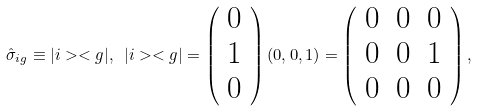<formula> <loc_0><loc_0><loc_500><loc_500>\hat { \sigma } _ { i g } \equiv | i > < g | , \text { } | i > < g | = \left ( \begin{array} { c c c c } 0 \\ 1 \\ 0 \end{array} \right ) ( 0 , 0 , 1 ) = \left ( \begin{array} { c c c c } 0 & 0 & 0 \\ 0 & 0 & 1 \\ 0 & 0 & 0 \end{array} \right ) ,</formula> 